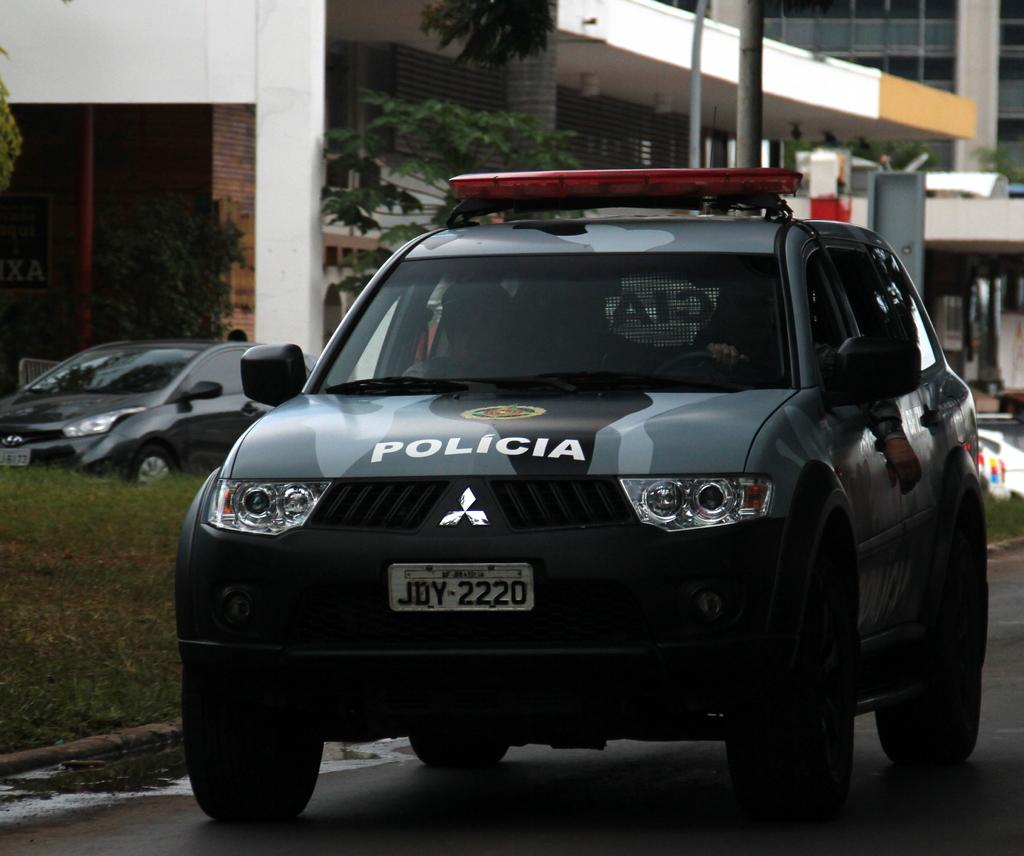What type of vehicles can be seen on the road in the image? There are cars on the road in the image. What can be seen in the distance behind the cars? There are buildings visible in the background of the image. How many snakes are slithering across the road in the image? There are no snakes present in the image; it features cars on the road and buildings in the background. 